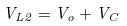<formula> <loc_0><loc_0><loc_500><loc_500>V _ { L 2 } = V _ { o } + V _ { C }</formula> 